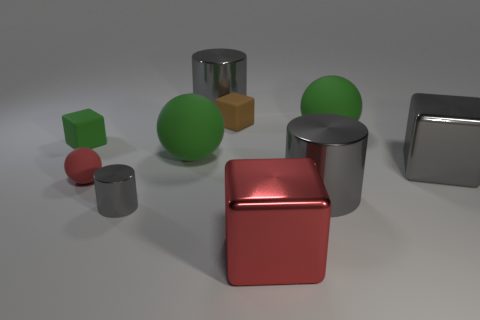How many red blocks are to the right of the big metal cylinder that is behind the red matte object?
Keep it short and to the point. 1. Does the big green thing that is on the left side of the large red object have the same shape as the small brown object?
Your answer should be very brief. No. There is a large red thing that is the same shape as the brown thing; what material is it?
Make the answer very short. Metal. How many brown objects are the same size as the red rubber object?
Offer a very short reply. 1. There is a tiny rubber object that is both on the right side of the green rubber cube and in front of the brown matte object; what color is it?
Offer a very short reply. Red. Is the number of tiny matte spheres less than the number of yellow spheres?
Provide a succinct answer. No. Is the color of the small cylinder the same as the large shiny cube that is in front of the red ball?
Make the answer very short. No. Are there the same number of gray cubes that are in front of the small red ball and tiny green matte cubes on the right side of the tiny gray metal object?
Make the answer very short. Yes. What number of tiny objects have the same shape as the big red thing?
Provide a short and direct response. 2. Are there any brown rubber cubes?
Ensure brevity in your answer.  Yes. 